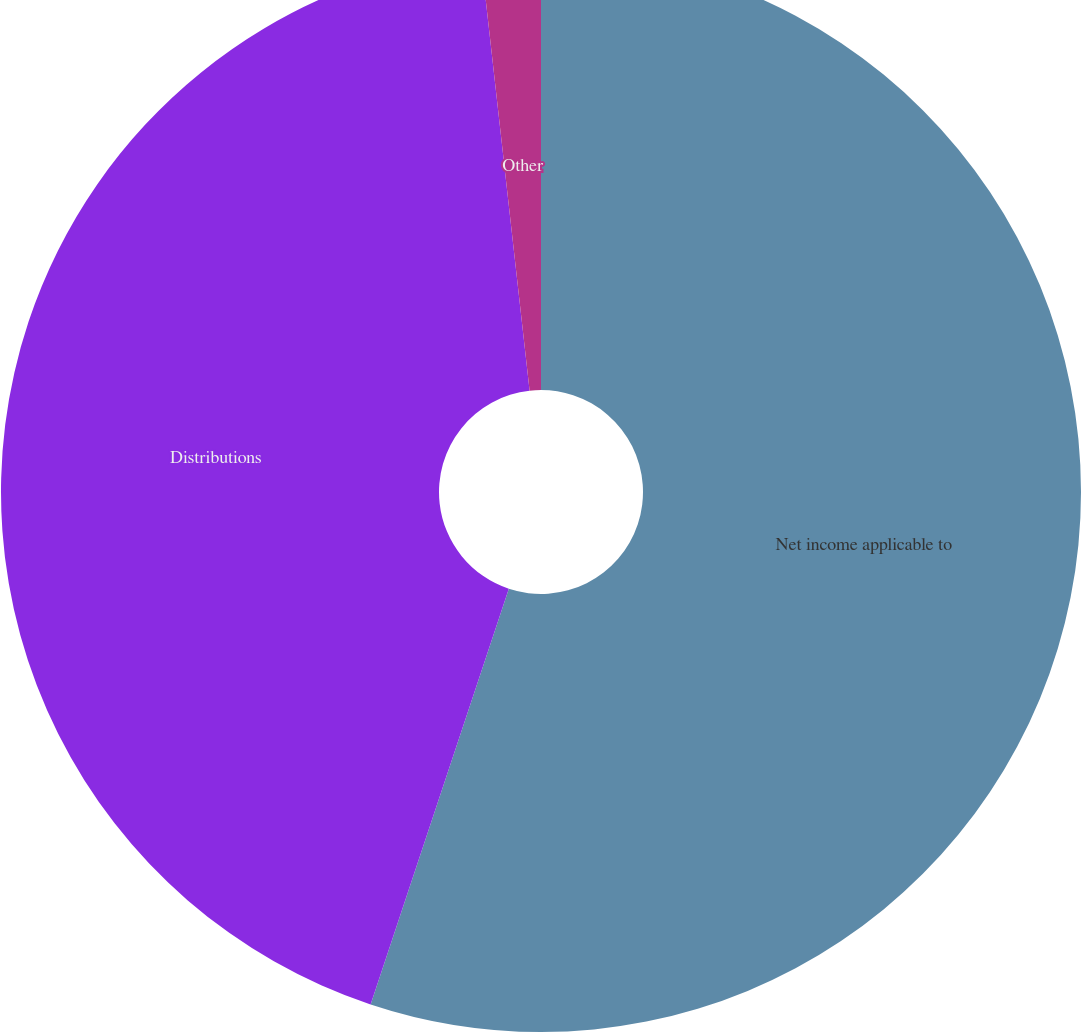Convert chart to OTSL. <chart><loc_0><loc_0><loc_500><loc_500><pie_chart><fcel>Net income applicable to<fcel>Distributions<fcel>Other<nl><fcel>55.11%<fcel>43.11%<fcel>1.78%<nl></chart> 